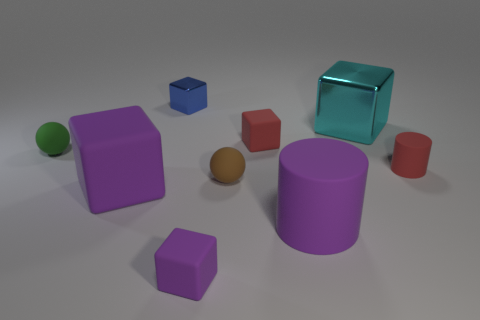Subtract all blocks. How many objects are left? 4 Add 1 spheres. How many objects exist? 10 Subtract all cyan blocks. How many blocks are left? 4 Subtract all purple matte cubes. How many cubes are left? 3 Subtract 2 spheres. How many spheres are left? 0 Add 6 tiny cylinders. How many tiny cylinders are left? 7 Add 4 purple rubber cylinders. How many purple rubber cylinders exist? 5 Subtract 0 yellow balls. How many objects are left? 9 Subtract all brown blocks. Subtract all brown cylinders. How many blocks are left? 5 Subtract all blue cylinders. How many red blocks are left? 1 